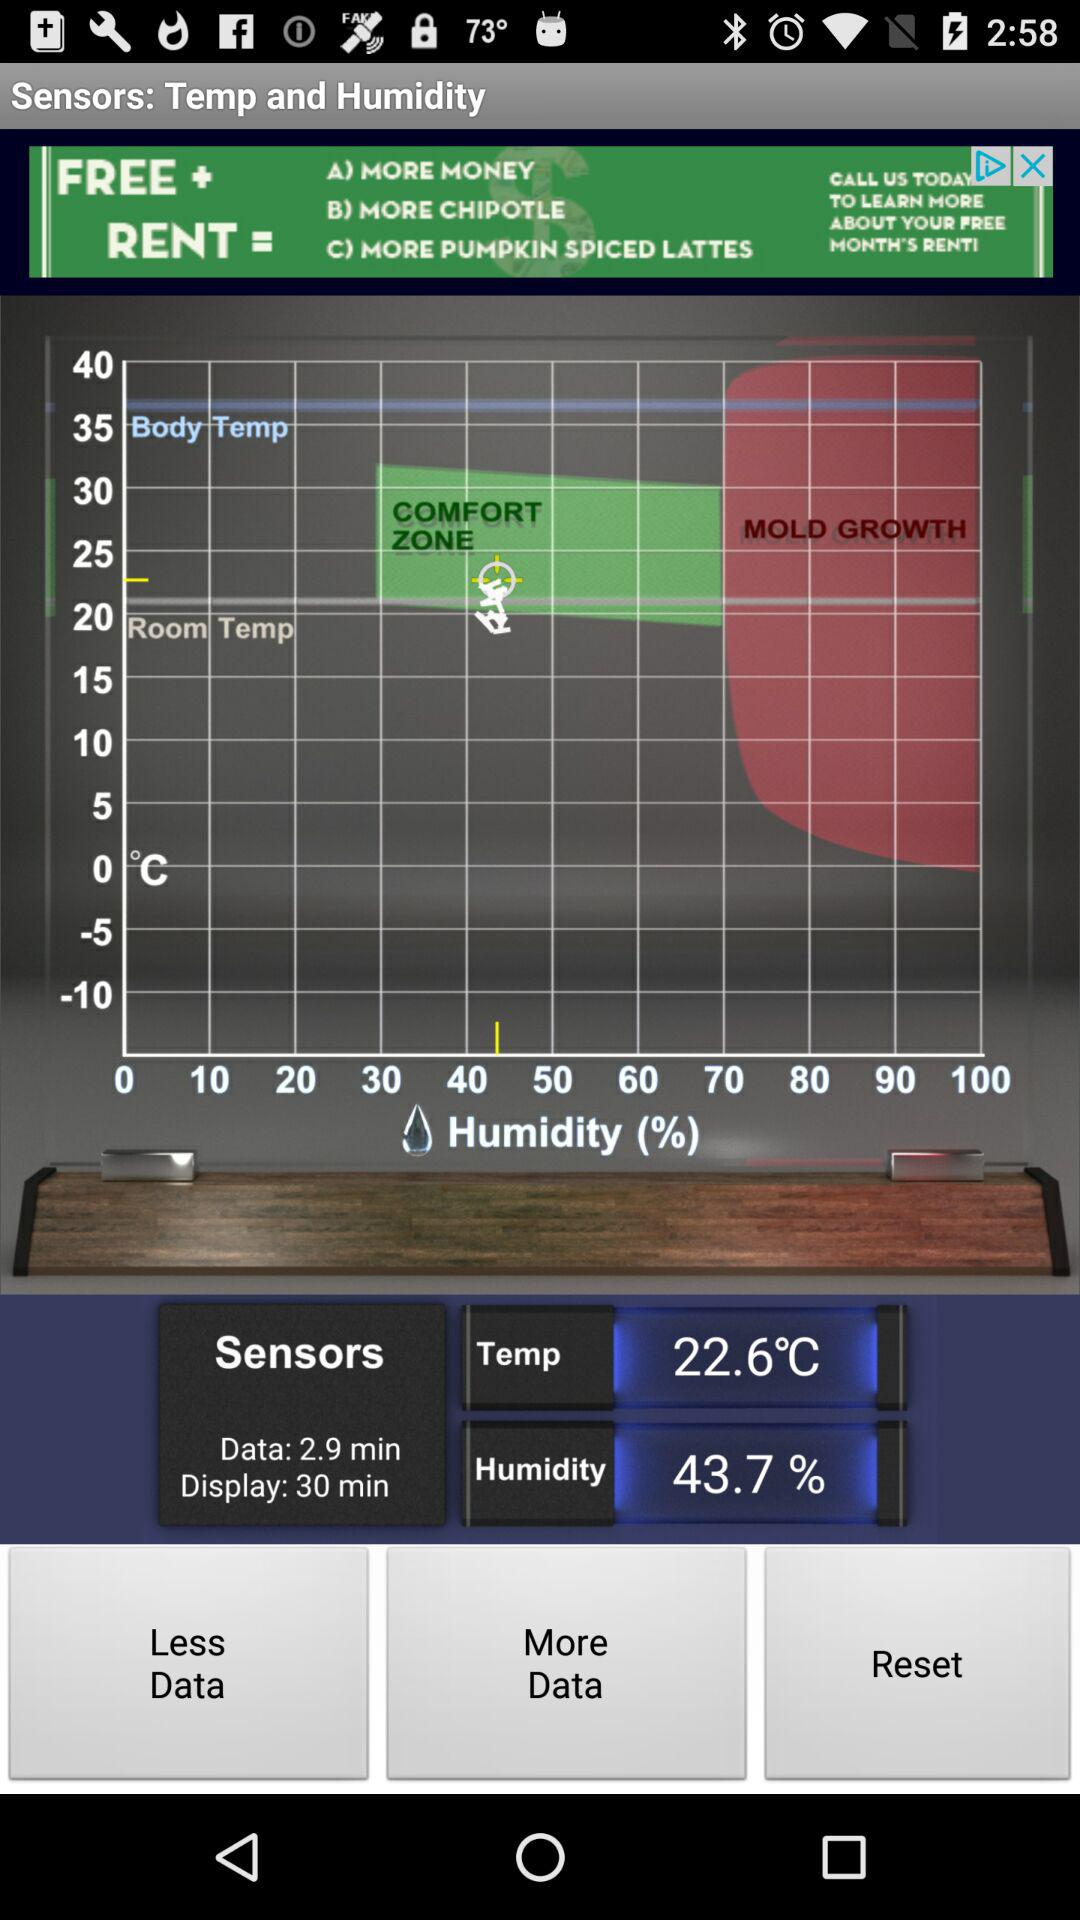What is the temperature? The temperature is 22.6°C. 